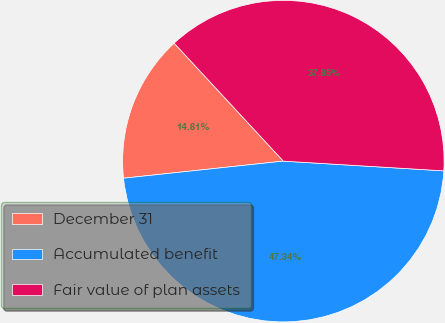Convert chart. <chart><loc_0><loc_0><loc_500><loc_500><pie_chart><fcel>December 31<fcel>Accumulated benefit<fcel>Fair value of plan assets<nl><fcel>14.81%<fcel>47.34%<fcel>37.85%<nl></chart> 